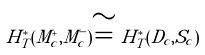<formula> <loc_0><loc_0><loc_500><loc_500>H ^ { * } _ { T } ( M _ { c } ^ { + } , M _ { c } ^ { - } ) \cong H ^ { * } _ { T } ( D _ { c } , S _ { c } )</formula> 